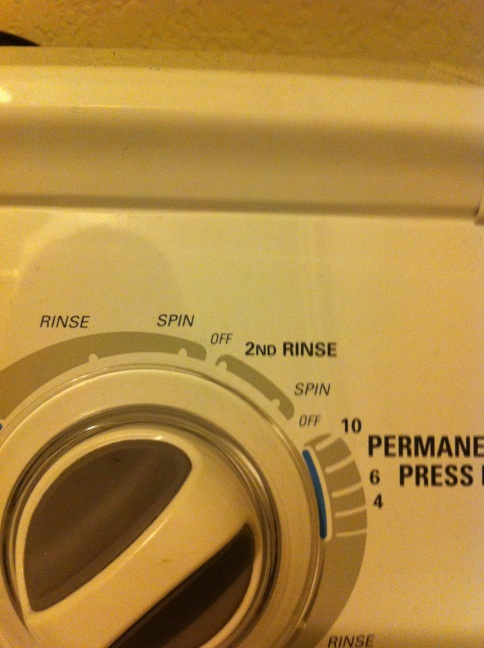What kind of clothes or fabrics should use the 'Spin' setting? The 'Spin' setting is best used for sturdy fabrics such as cotton, denim, and towels that can withstand high-speed spinning to remove excess water. It helps reduce drying time and leaves the clothes less damp. However, delicate fabrics like silk or lace should avoid high-spin settings to prevent damage. 